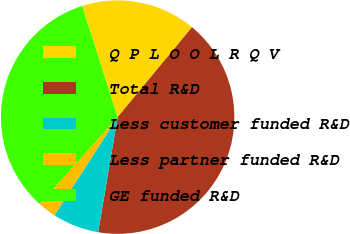Convert chart to OTSL. <chart><loc_0><loc_0><loc_500><loc_500><pie_chart><fcel>Q P L O O L R Q V<fcel>Total R&D<fcel>Less customer funded R&D<fcel>Less partner funded R&D<fcel>GE funded R&D<nl><fcel>15.92%<fcel>41.67%<fcel>6.44%<fcel>2.52%<fcel>33.45%<nl></chart> 